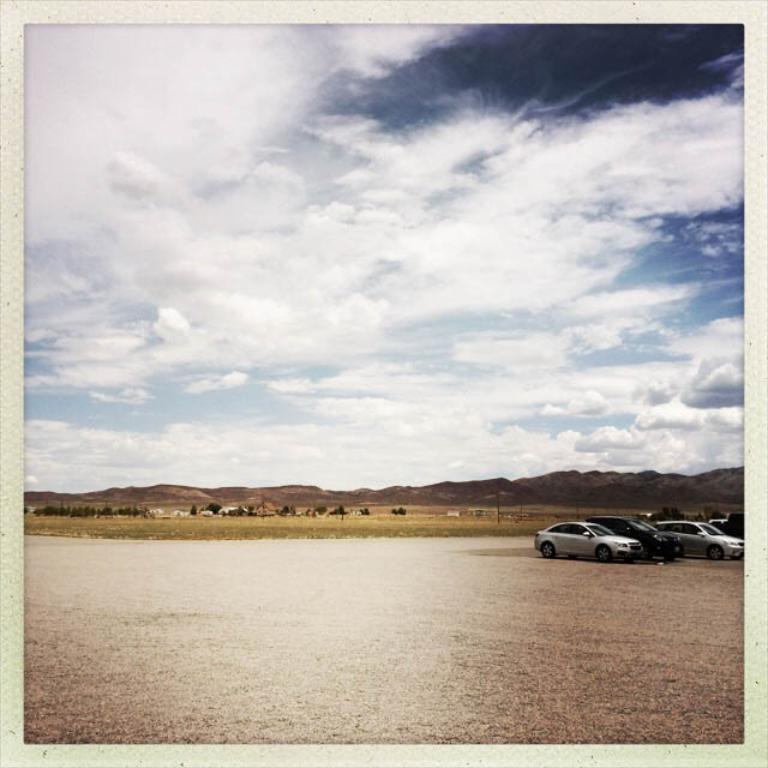What type of vehicles are present in the image? There are cars in the image. Can you describe the colors of the cars? The cars are in gray and black colors. What other living creatures can be seen in the image? There are animals visible in the image. What type of natural landscape is present in the image? There are mountains in the image. How would you describe the color of the sky? The sky is white and gray in color. Reasoning: Let' Let's think step by step in order to produce the conversation. We start by identifying the main subject in the image, which are the cars. Then, we expand the conversation to include details about the colors of the cars, the presence of animals, the natural landscape, and the color of the sky. Each question is designed to elicit a specific detail about the image that is known from the provided facts. Absurd Question/Answer: What type of corn is being harvested in the image? There is no corn present in the image; it features cars, animals, mountains, and a sky with white and gray colors. Is there a memory card visible in the image? There is no mention of a memory card in the provided facts, and it is not visible in the image. --- Facts: 1. There is a person sitting on a chair in the image. 2. The person is holding a book. 3. The book has a red cover. 4. There is a table next to the chair. 5. There is a lamp on the table. Absurd Topics: parrot, ocean, bicycle Conversation: What is the person in the image doing? The person is sitting on a chair in the image. What object is the person holding? The person is holding a book. Can you describe the book's appearance? The book has a red cover. What is located next to the chair? There is a table next to the chair. What is on the table? There is a lamp on the table. Reasoning: Let's think step by step in order to produce the conversation. We start by identifying the main subject in the image, which is the person sitting on a chair. Then, we expand the conversation to include details about the object the person is holding (a book), the appearance of the book (red cover), and the presence of a table and 